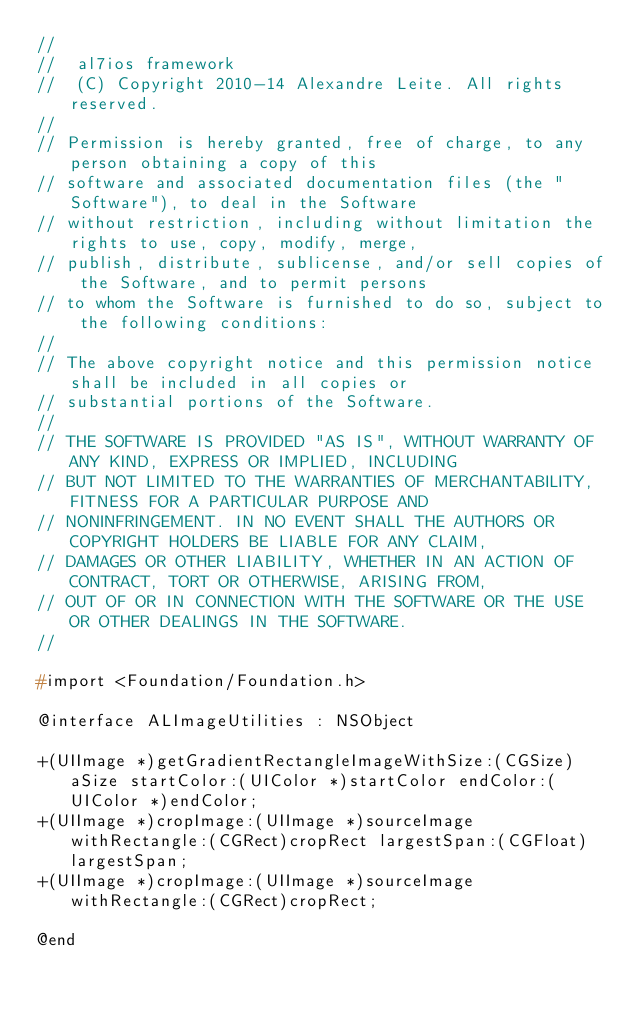<code> <loc_0><loc_0><loc_500><loc_500><_C_>//
//  al7ios framework
//  (C) Copyright 2010-14 Alexandre Leite. All rights reserved. 
//
// Permission is hereby granted, free of charge, to any person obtaining a copy of this
// software and associated documentation files (the "Software"), to deal in the Software
// without restriction, including without limitation the rights to use, copy, modify, merge,
// publish, distribute, sublicense, and/or sell copies of the Software, and to permit persons
// to whom the Software is furnished to do so, subject to the following conditions:
//
// The above copyright notice and this permission notice shall be included in all copies or
// substantial portions of the Software.
//
// THE SOFTWARE IS PROVIDED "AS IS", WITHOUT WARRANTY OF ANY KIND, EXPRESS OR IMPLIED, INCLUDING 
// BUT NOT LIMITED TO THE WARRANTIES OF MERCHANTABILITY, FITNESS FOR A PARTICULAR PURPOSE AND 
// NONINFRINGEMENT. IN NO EVENT SHALL THE AUTHORS OR COPYRIGHT HOLDERS BE LIABLE FOR ANY CLAIM, 
// DAMAGES OR OTHER LIABILITY, WHETHER IN AN ACTION OF CONTRACT, TORT OR OTHERWISE, ARISING FROM,
// OUT OF OR IN CONNECTION WITH THE SOFTWARE OR THE USE OR OTHER DEALINGS IN THE SOFTWARE.
//

#import <Foundation/Foundation.h>

@interface ALImageUtilities : NSObject

+(UIImage *)getGradientRectangleImageWithSize:(CGSize)aSize startColor:(UIColor *)startColor endColor:(UIColor *)endColor;
+(UIImage *)cropImage:(UIImage *)sourceImage withRectangle:(CGRect)cropRect largestSpan:(CGFloat)largestSpan;
+(UIImage *)cropImage:(UIImage *)sourceImage withRectangle:(CGRect)cropRect;

@end
</code> 